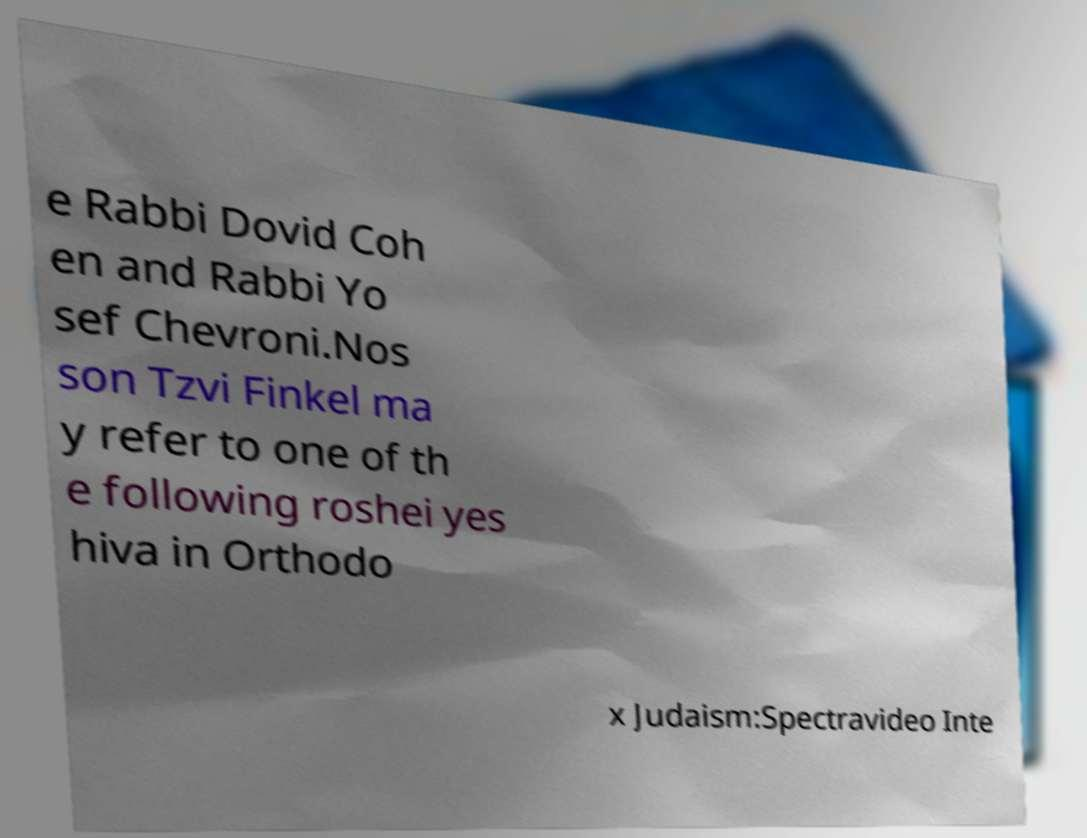For documentation purposes, I need the text within this image transcribed. Could you provide that? e Rabbi Dovid Coh en and Rabbi Yo sef Chevroni.Nos son Tzvi Finkel ma y refer to one of th e following roshei yes hiva in Orthodo x Judaism:Spectravideo Inte 